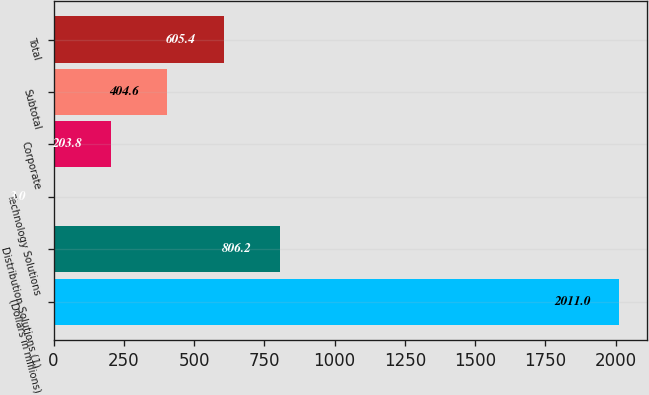Convert chart to OTSL. <chart><loc_0><loc_0><loc_500><loc_500><bar_chart><fcel>(Dollars in millions)<fcel>Distribution Solutions (1)<fcel>Technology Solutions<fcel>Corporate<fcel>Subtotal<fcel>Total<nl><fcel>2011<fcel>806.2<fcel>3<fcel>203.8<fcel>404.6<fcel>605.4<nl></chart> 